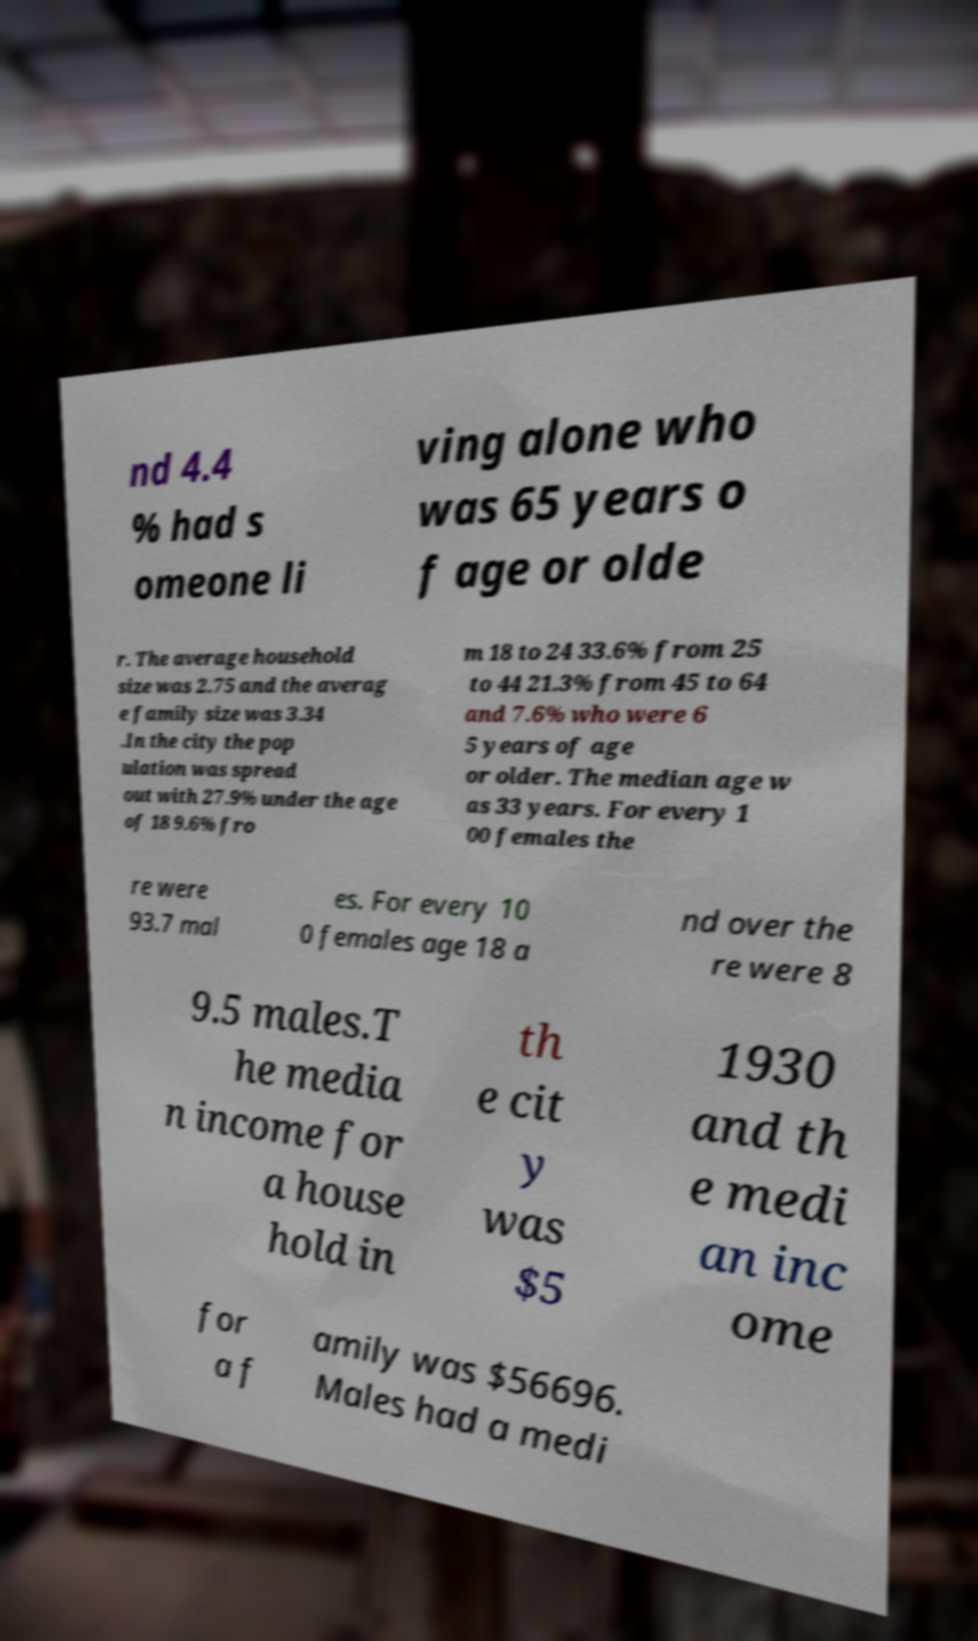What messages or text are displayed in this image? I need them in a readable, typed format. nd 4.4 % had s omeone li ving alone who was 65 years o f age or olde r. The average household size was 2.75 and the averag e family size was 3.34 .In the city the pop ulation was spread out with 27.9% under the age of 18 9.6% fro m 18 to 24 33.6% from 25 to 44 21.3% from 45 to 64 and 7.6% who were 6 5 years of age or older. The median age w as 33 years. For every 1 00 females the re were 93.7 mal es. For every 10 0 females age 18 a nd over the re were 8 9.5 males.T he media n income for a house hold in th e cit y was $5 1930 and th e medi an inc ome for a f amily was $56696. Males had a medi 